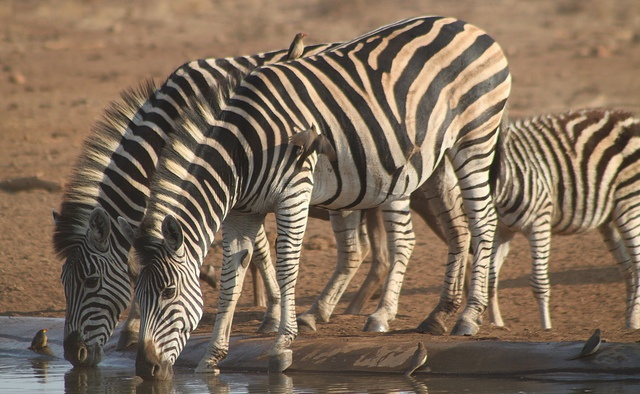Describe the objects in this image and their specific colors. I can see zebra in gray, black, and tan tones, zebra in gray and black tones, zebra in gray and tan tones, bird in gray and black tones, and bird in gray, black, and tan tones in this image. 